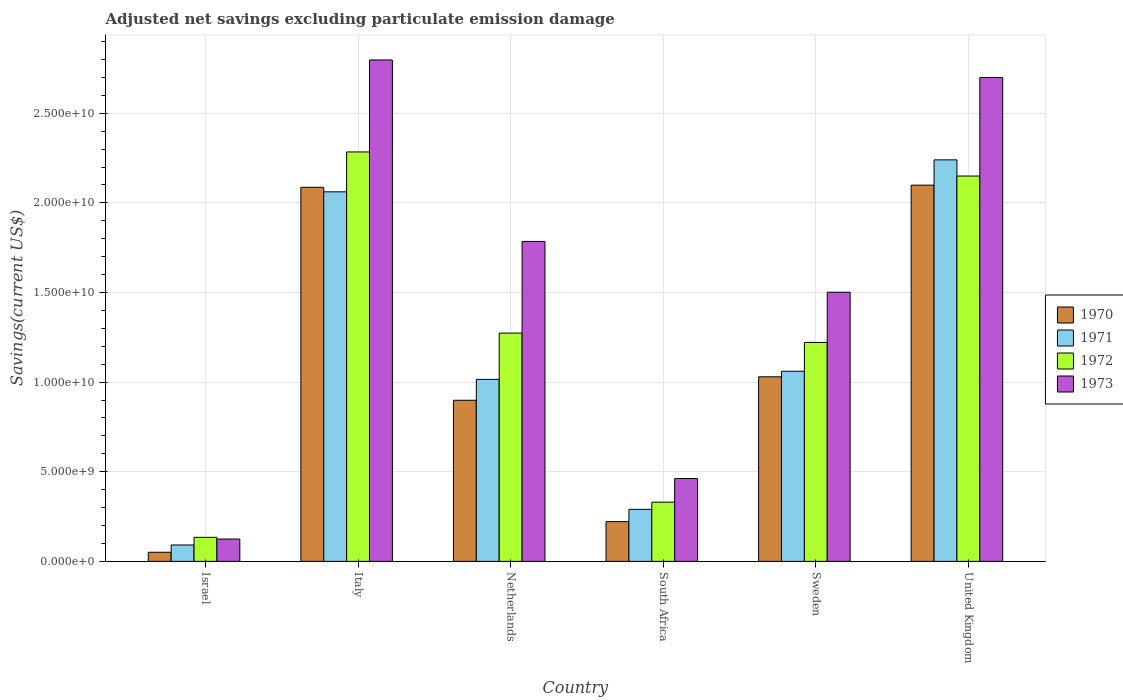How many different coloured bars are there?
Keep it short and to the point. 4. In how many cases, is the number of bars for a given country not equal to the number of legend labels?
Offer a very short reply. 0. What is the adjusted net savings in 1970 in Sweden?
Provide a succinct answer. 1.03e+1. Across all countries, what is the maximum adjusted net savings in 1973?
Your response must be concise. 2.80e+1. Across all countries, what is the minimum adjusted net savings in 1970?
Ensure brevity in your answer.  5.08e+08. What is the total adjusted net savings in 1970 in the graph?
Provide a short and direct response. 6.39e+1. What is the difference between the adjusted net savings in 1973 in Netherlands and that in South Africa?
Offer a very short reply. 1.32e+1. What is the difference between the adjusted net savings in 1972 in Sweden and the adjusted net savings in 1971 in Netherlands?
Provide a short and direct response. 2.06e+09. What is the average adjusted net savings in 1971 per country?
Your answer should be compact. 1.13e+1. What is the difference between the adjusted net savings of/in 1970 and adjusted net savings of/in 1971 in Israel?
Make the answer very short. -4.06e+08. In how many countries, is the adjusted net savings in 1973 greater than 8000000000 US$?
Offer a very short reply. 4. What is the ratio of the adjusted net savings in 1971 in Israel to that in Italy?
Make the answer very short. 0.04. Is the adjusted net savings in 1970 in Netherlands less than that in United Kingdom?
Make the answer very short. Yes. What is the difference between the highest and the second highest adjusted net savings in 1971?
Provide a short and direct response. -1.18e+1. What is the difference between the highest and the lowest adjusted net savings in 1971?
Make the answer very short. 2.15e+1. What does the 4th bar from the right in Italy represents?
Make the answer very short. 1970. Is it the case that in every country, the sum of the adjusted net savings in 1973 and adjusted net savings in 1971 is greater than the adjusted net savings in 1970?
Make the answer very short. Yes. How many bars are there?
Offer a very short reply. 24. Are all the bars in the graph horizontal?
Offer a very short reply. No. How many countries are there in the graph?
Your response must be concise. 6. What is the difference between two consecutive major ticks on the Y-axis?
Keep it short and to the point. 5.00e+09. Are the values on the major ticks of Y-axis written in scientific E-notation?
Offer a very short reply. Yes. Does the graph contain any zero values?
Your response must be concise. No. Does the graph contain grids?
Keep it short and to the point. Yes. Where does the legend appear in the graph?
Provide a short and direct response. Center right. How many legend labels are there?
Provide a succinct answer. 4. What is the title of the graph?
Offer a very short reply. Adjusted net savings excluding particulate emission damage. What is the label or title of the X-axis?
Your response must be concise. Country. What is the label or title of the Y-axis?
Ensure brevity in your answer.  Savings(current US$). What is the Savings(current US$) of 1970 in Israel?
Give a very brief answer. 5.08e+08. What is the Savings(current US$) of 1971 in Israel?
Ensure brevity in your answer.  9.14e+08. What is the Savings(current US$) of 1972 in Israel?
Offer a very short reply. 1.34e+09. What is the Savings(current US$) of 1973 in Israel?
Offer a very short reply. 1.25e+09. What is the Savings(current US$) in 1970 in Italy?
Offer a very short reply. 2.09e+1. What is the Savings(current US$) in 1971 in Italy?
Provide a short and direct response. 2.06e+1. What is the Savings(current US$) of 1972 in Italy?
Provide a short and direct response. 2.28e+1. What is the Savings(current US$) of 1973 in Italy?
Keep it short and to the point. 2.80e+1. What is the Savings(current US$) of 1970 in Netherlands?
Ensure brevity in your answer.  8.99e+09. What is the Savings(current US$) of 1971 in Netherlands?
Keep it short and to the point. 1.02e+1. What is the Savings(current US$) of 1972 in Netherlands?
Ensure brevity in your answer.  1.27e+1. What is the Savings(current US$) in 1973 in Netherlands?
Offer a very short reply. 1.79e+1. What is the Savings(current US$) in 1970 in South Africa?
Your response must be concise. 2.22e+09. What is the Savings(current US$) in 1971 in South Africa?
Your response must be concise. 2.90e+09. What is the Savings(current US$) of 1972 in South Africa?
Provide a short and direct response. 3.30e+09. What is the Savings(current US$) in 1973 in South Africa?
Keep it short and to the point. 4.62e+09. What is the Savings(current US$) of 1970 in Sweden?
Your response must be concise. 1.03e+1. What is the Savings(current US$) of 1971 in Sweden?
Keep it short and to the point. 1.06e+1. What is the Savings(current US$) of 1972 in Sweden?
Provide a succinct answer. 1.22e+1. What is the Savings(current US$) in 1973 in Sweden?
Keep it short and to the point. 1.50e+1. What is the Savings(current US$) in 1970 in United Kingdom?
Give a very brief answer. 2.10e+1. What is the Savings(current US$) in 1971 in United Kingdom?
Offer a terse response. 2.24e+1. What is the Savings(current US$) in 1972 in United Kingdom?
Make the answer very short. 2.15e+1. What is the Savings(current US$) in 1973 in United Kingdom?
Offer a very short reply. 2.70e+1. Across all countries, what is the maximum Savings(current US$) in 1970?
Make the answer very short. 2.10e+1. Across all countries, what is the maximum Savings(current US$) in 1971?
Your answer should be very brief. 2.24e+1. Across all countries, what is the maximum Savings(current US$) in 1972?
Keep it short and to the point. 2.28e+1. Across all countries, what is the maximum Savings(current US$) in 1973?
Your response must be concise. 2.80e+1. Across all countries, what is the minimum Savings(current US$) of 1970?
Ensure brevity in your answer.  5.08e+08. Across all countries, what is the minimum Savings(current US$) of 1971?
Your answer should be compact. 9.14e+08. Across all countries, what is the minimum Savings(current US$) in 1972?
Offer a very short reply. 1.34e+09. Across all countries, what is the minimum Savings(current US$) in 1973?
Offer a very short reply. 1.25e+09. What is the total Savings(current US$) of 1970 in the graph?
Provide a succinct answer. 6.39e+1. What is the total Savings(current US$) of 1971 in the graph?
Your answer should be compact. 6.76e+1. What is the total Savings(current US$) of 1972 in the graph?
Keep it short and to the point. 7.39e+1. What is the total Savings(current US$) in 1973 in the graph?
Make the answer very short. 9.37e+1. What is the difference between the Savings(current US$) in 1970 in Israel and that in Italy?
Give a very brief answer. -2.04e+1. What is the difference between the Savings(current US$) in 1971 in Israel and that in Italy?
Keep it short and to the point. -1.97e+1. What is the difference between the Savings(current US$) in 1972 in Israel and that in Italy?
Ensure brevity in your answer.  -2.15e+1. What is the difference between the Savings(current US$) in 1973 in Israel and that in Italy?
Keep it short and to the point. -2.67e+1. What is the difference between the Savings(current US$) of 1970 in Israel and that in Netherlands?
Make the answer very short. -8.48e+09. What is the difference between the Savings(current US$) in 1971 in Israel and that in Netherlands?
Provide a short and direct response. -9.24e+09. What is the difference between the Savings(current US$) in 1972 in Israel and that in Netherlands?
Provide a short and direct response. -1.14e+1. What is the difference between the Savings(current US$) of 1973 in Israel and that in Netherlands?
Provide a short and direct response. -1.66e+1. What is the difference between the Savings(current US$) in 1970 in Israel and that in South Africa?
Offer a very short reply. -1.71e+09. What is the difference between the Savings(current US$) of 1971 in Israel and that in South Africa?
Ensure brevity in your answer.  -1.99e+09. What is the difference between the Savings(current US$) of 1972 in Israel and that in South Africa?
Your answer should be compact. -1.96e+09. What is the difference between the Savings(current US$) in 1973 in Israel and that in South Africa?
Your answer should be compact. -3.38e+09. What is the difference between the Savings(current US$) in 1970 in Israel and that in Sweden?
Keep it short and to the point. -9.79e+09. What is the difference between the Savings(current US$) in 1971 in Israel and that in Sweden?
Offer a terse response. -9.69e+09. What is the difference between the Savings(current US$) of 1972 in Israel and that in Sweden?
Provide a succinct answer. -1.09e+1. What is the difference between the Savings(current US$) of 1973 in Israel and that in Sweden?
Your response must be concise. -1.38e+1. What is the difference between the Savings(current US$) of 1970 in Israel and that in United Kingdom?
Offer a terse response. -2.05e+1. What is the difference between the Savings(current US$) in 1971 in Israel and that in United Kingdom?
Offer a terse response. -2.15e+1. What is the difference between the Savings(current US$) of 1972 in Israel and that in United Kingdom?
Provide a short and direct response. -2.02e+1. What is the difference between the Savings(current US$) of 1973 in Israel and that in United Kingdom?
Offer a very short reply. -2.58e+1. What is the difference between the Savings(current US$) of 1970 in Italy and that in Netherlands?
Provide a short and direct response. 1.19e+1. What is the difference between the Savings(current US$) of 1971 in Italy and that in Netherlands?
Offer a terse response. 1.05e+1. What is the difference between the Savings(current US$) in 1972 in Italy and that in Netherlands?
Give a very brief answer. 1.01e+1. What is the difference between the Savings(current US$) in 1973 in Italy and that in Netherlands?
Keep it short and to the point. 1.01e+1. What is the difference between the Savings(current US$) of 1970 in Italy and that in South Africa?
Keep it short and to the point. 1.87e+1. What is the difference between the Savings(current US$) of 1971 in Italy and that in South Africa?
Provide a succinct answer. 1.77e+1. What is the difference between the Savings(current US$) of 1972 in Italy and that in South Africa?
Provide a succinct answer. 1.95e+1. What is the difference between the Savings(current US$) in 1973 in Italy and that in South Africa?
Give a very brief answer. 2.34e+1. What is the difference between the Savings(current US$) in 1970 in Italy and that in Sweden?
Ensure brevity in your answer.  1.06e+1. What is the difference between the Savings(current US$) in 1971 in Italy and that in Sweden?
Ensure brevity in your answer.  1.00e+1. What is the difference between the Savings(current US$) of 1972 in Italy and that in Sweden?
Give a very brief answer. 1.06e+1. What is the difference between the Savings(current US$) of 1973 in Italy and that in Sweden?
Your answer should be very brief. 1.30e+1. What is the difference between the Savings(current US$) in 1970 in Italy and that in United Kingdom?
Your response must be concise. -1.20e+08. What is the difference between the Savings(current US$) in 1971 in Italy and that in United Kingdom?
Keep it short and to the point. -1.78e+09. What is the difference between the Savings(current US$) of 1972 in Italy and that in United Kingdom?
Offer a very short reply. 1.34e+09. What is the difference between the Savings(current US$) in 1973 in Italy and that in United Kingdom?
Keep it short and to the point. 9.78e+08. What is the difference between the Savings(current US$) of 1970 in Netherlands and that in South Africa?
Offer a very short reply. 6.77e+09. What is the difference between the Savings(current US$) in 1971 in Netherlands and that in South Africa?
Your answer should be compact. 7.25e+09. What is the difference between the Savings(current US$) of 1972 in Netherlands and that in South Africa?
Offer a terse response. 9.43e+09. What is the difference between the Savings(current US$) in 1973 in Netherlands and that in South Africa?
Give a very brief answer. 1.32e+1. What is the difference between the Savings(current US$) in 1970 in Netherlands and that in Sweden?
Provide a succinct answer. -1.31e+09. What is the difference between the Savings(current US$) in 1971 in Netherlands and that in Sweden?
Your answer should be compact. -4.54e+08. What is the difference between the Savings(current US$) of 1972 in Netherlands and that in Sweden?
Keep it short and to the point. 5.20e+08. What is the difference between the Savings(current US$) in 1973 in Netherlands and that in Sweden?
Offer a terse response. 2.83e+09. What is the difference between the Savings(current US$) of 1970 in Netherlands and that in United Kingdom?
Provide a short and direct response. -1.20e+1. What is the difference between the Savings(current US$) of 1971 in Netherlands and that in United Kingdom?
Provide a short and direct response. -1.22e+1. What is the difference between the Savings(current US$) in 1972 in Netherlands and that in United Kingdom?
Ensure brevity in your answer.  -8.76e+09. What is the difference between the Savings(current US$) in 1973 in Netherlands and that in United Kingdom?
Your answer should be compact. -9.15e+09. What is the difference between the Savings(current US$) of 1970 in South Africa and that in Sweden?
Keep it short and to the point. -8.08e+09. What is the difference between the Savings(current US$) of 1971 in South Africa and that in Sweden?
Offer a very short reply. -7.70e+09. What is the difference between the Savings(current US$) in 1972 in South Africa and that in Sweden?
Offer a terse response. -8.91e+09. What is the difference between the Savings(current US$) in 1973 in South Africa and that in Sweden?
Your answer should be very brief. -1.04e+1. What is the difference between the Savings(current US$) of 1970 in South Africa and that in United Kingdom?
Provide a succinct answer. -1.88e+1. What is the difference between the Savings(current US$) in 1971 in South Africa and that in United Kingdom?
Your response must be concise. -1.95e+1. What is the difference between the Savings(current US$) in 1972 in South Africa and that in United Kingdom?
Your answer should be compact. -1.82e+1. What is the difference between the Savings(current US$) of 1973 in South Africa and that in United Kingdom?
Your answer should be very brief. -2.24e+1. What is the difference between the Savings(current US$) of 1970 in Sweden and that in United Kingdom?
Your answer should be very brief. -1.07e+1. What is the difference between the Savings(current US$) of 1971 in Sweden and that in United Kingdom?
Your response must be concise. -1.18e+1. What is the difference between the Savings(current US$) in 1972 in Sweden and that in United Kingdom?
Ensure brevity in your answer.  -9.28e+09. What is the difference between the Savings(current US$) in 1973 in Sweden and that in United Kingdom?
Ensure brevity in your answer.  -1.20e+1. What is the difference between the Savings(current US$) of 1970 in Israel and the Savings(current US$) of 1971 in Italy?
Provide a short and direct response. -2.01e+1. What is the difference between the Savings(current US$) in 1970 in Israel and the Savings(current US$) in 1972 in Italy?
Keep it short and to the point. -2.23e+1. What is the difference between the Savings(current US$) of 1970 in Israel and the Savings(current US$) of 1973 in Italy?
Your answer should be very brief. -2.75e+1. What is the difference between the Savings(current US$) of 1971 in Israel and the Savings(current US$) of 1972 in Italy?
Provide a succinct answer. -2.19e+1. What is the difference between the Savings(current US$) of 1971 in Israel and the Savings(current US$) of 1973 in Italy?
Offer a terse response. -2.71e+1. What is the difference between the Savings(current US$) in 1972 in Israel and the Savings(current US$) in 1973 in Italy?
Your response must be concise. -2.66e+1. What is the difference between the Savings(current US$) in 1970 in Israel and the Savings(current US$) in 1971 in Netherlands?
Offer a very short reply. -9.65e+09. What is the difference between the Savings(current US$) of 1970 in Israel and the Savings(current US$) of 1972 in Netherlands?
Your answer should be compact. -1.22e+1. What is the difference between the Savings(current US$) in 1970 in Israel and the Savings(current US$) in 1973 in Netherlands?
Your answer should be compact. -1.73e+1. What is the difference between the Savings(current US$) in 1971 in Israel and the Savings(current US$) in 1972 in Netherlands?
Ensure brevity in your answer.  -1.18e+1. What is the difference between the Savings(current US$) in 1971 in Israel and the Savings(current US$) in 1973 in Netherlands?
Ensure brevity in your answer.  -1.69e+1. What is the difference between the Savings(current US$) in 1972 in Israel and the Savings(current US$) in 1973 in Netherlands?
Your answer should be very brief. -1.65e+1. What is the difference between the Savings(current US$) of 1970 in Israel and the Savings(current US$) of 1971 in South Africa?
Your response must be concise. -2.39e+09. What is the difference between the Savings(current US$) in 1970 in Israel and the Savings(current US$) in 1972 in South Africa?
Give a very brief answer. -2.79e+09. What is the difference between the Savings(current US$) in 1970 in Israel and the Savings(current US$) in 1973 in South Africa?
Your response must be concise. -4.11e+09. What is the difference between the Savings(current US$) in 1971 in Israel and the Savings(current US$) in 1972 in South Africa?
Your response must be concise. -2.39e+09. What is the difference between the Savings(current US$) in 1971 in Israel and the Savings(current US$) in 1973 in South Africa?
Provide a succinct answer. -3.71e+09. What is the difference between the Savings(current US$) of 1972 in Israel and the Savings(current US$) of 1973 in South Africa?
Give a very brief answer. -3.28e+09. What is the difference between the Savings(current US$) of 1970 in Israel and the Savings(current US$) of 1971 in Sweden?
Ensure brevity in your answer.  -1.01e+1. What is the difference between the Savings(current US$) of 1970 in Israel and the Savings(current US$) of 1972 in Sweden?
Ensure brevity in your answer.  -1.17e+1. What is the difference between the Savings(current US$) in 1970 in Israel and the Savings(current US$) in 1973 in Sweden?
Provide a succinct answer. -1.45e+1. What is the difference between the Savings(current US$) in 1971 in Israel and the Savings(current US$) in 1972 in Sweden?
Ensure brevity in your answer.  -1.13e+1. What is the difference between the Savings(current US$) of 1971 in Israel and the Savings(current US$) of 1973 in Sweden?
Keep it short and to the point. -1.41e+1. What is the difference between the Savings(current US$) in 1972 in Israel and the Savings(current US$) in 1973 in Sweden?
Make the answer very short. -1.37e+1. What is the difference between the Savings(current US$) of 1970 in Israel and the Savings(current US$) of 1971 in United Kingdom?
Your response must be concise. -2.19e+1. What is the difference between the Savings(current US$) in 1970 in Israel and the Savings(current US$) in 1972 in United Kingdom?
Offer a terse response. -2.10e+1. What is the difference between the Savings(current US$) of 1970 in Israel and the Savings(current US$) of 1973 in United Kingdom?
Keep it short and to the point. -2.65e+1. What is the difference between the Savings(current US$) in 1971 in Israel and the Savings(current US$) in 1972 in United Kingdom?
Your response must be concise. -2.06e+1. What is the difference between the Savings(current US$) in 1971 in Israel and the Savings(current US$) in 1973 in United Kingdom?
Offer a very short reply. -2.61e+1. What is the difference between the Savings(current US$) of 1972 in Israel and the Savings(current US$) of 1973 in United Kingdom?
Provide a short and direct response. -2.57e+1. What is the difference between the Savings(current US$) in 1970 in Italy and the Savings(current US$) in 1971 in Netherlands?
Provide a short and direct response. 1.07e+1. What is the difference between the Savings(current US$) of 1970 in Italy and the Savings(current US$) of 1972 in Netherlands?
Provide a succinct answer. 8.14e+09. What is the difference between the Savings(current US$) of 1970 in Italy and the Savings(current US$) of 1973 in Netherlands?
Give a very brief answer. 3.02e+09. What is the difference between the Savings(current US$) of 1971 in Italy and the Savings(current US$) of 1972 in Netherlands?
Your response must be concise. 7.88e+09. What is the difference between the Savings(current US$) in 1971 in Italy and the Savings(current US$) in 1973 in Netherlands?
Your answer should be compact. 2.77e+09. What is the difference between the Savings(current US$) of 1972 in Italy and the Savings(current US$) of 1973 in Netherlands?
Give a very brief answer. 4.99e+09. What is the difference between the Savings(current US$) of 1970 in Italy and the Savings(current US$) of 1971 in South Africa?
Offer a very short reply. 1.80e+1. What is the difference between the Savings(current US$) in 1970 in Italy and the Savings(current US$) in 1972 in South Africa?
Offer a very short reply. 1.76e+1. What is the difference between the Savings(current US$) in 1970 in Italy and the Savings(current US$) in 1973 in South Africa?
Your answer should be very brief. 1.62e+1. What is the difference between the Savings(current US$) of 1971 in Italy and the Savings(current US$) of 1972 in South Africa?
Your response must be concise. 1.73e+1. What is the difference between the Savings(current US$) in 1971 in Italy and the Savings(current US$) in 1973 in South Africa?
Your answer should be very brief. 1.60e+1. What is the difference between the Savings(current US$) of 1972 in Italy and the Savings(current US$) of 1973 in South Africa?
Provide a succinct answer. 1.82e+1. What is the difference between the Savings(current US$) of 1970 in Italy and the Savings(current US$) of 1971 in Sweden?
Your response must be concise. 1.03e+1. What is the difference between the Savings(current US$) in 1970 in Italy and the Savings(current US$) in 1972 in Sweden?
Your response must be concise. 8.66e+09. What is the difference between the Savings(current US$) in 1970 in Italy and the Savings(current US$) in 1973 in Sweden?
Keep it short and to the point. 5.85e+09. What is the difference between the Savings(current US$) of 1971 in Italy and the Savings(current US$) of 1972 in Sweden?
Make the answer very short. 8.40e+09. What is the difference between the Savings(current US$) of 1971 in Italy and the Savings(current US$) of 1973 in Sweden?
Your response must be concise. 5.60e+09. What is the difference between the Savings(current US$) in 1972 in Italy and the Savings(current US$) in 1973 in Sweden?
Keep it short and to the point. 7.83e+09. What is the difference between the Savings(current US$) in 1970 in Italy and the Savings(current US$) in 1971 in United Kingdom?
Make the answer very short. -1.53e+09. What is the difference between the Savings(current US$) of 1970 in Italy and the Savings(current US$) of 1972 in United Kingdom?
Make the answer very short. -6.28e+08. What is the difference between the Savings(current US$) of 1970 in Italy and the Savings(current US$) of 1973 in United Kingdom?
Make the answer very short. -6.13e+09. What is the difference between the Savings(current US$) in 1971 in Italy and the Savings(current US$) in 1972 in United Kingdom?
Provide a succinct answer. -8.80e+08. What is the difference between the Savings(current US$) of 1971 in Italy and the Savings(current US$) of 1973 in United Kingdom?
Your answer should be very brief. -6.38e+09. What is the difference between the Savings(current US$) in 1972 in Italy and the Savings(current US$) in 1973 in United Kingdom?
Your response must be concise. -4.15e+09. What is the difference between the Savings(current US$) in 1970 in Netherlands and the Savings(current US$) in 1971 in South Africa?
Make the answer very short. 6.09e+09. What is the difference between the Savings(current US$) in 1970 in Netherlands and the Savings(current US$) in 1972 in South Africa?
Make the answer very short. 5.69e+09. What is the difference between the Savings(current US$) in 1970 in Netherlands and the Savings(current US$) in 1973 in South Africa?
Offer a terse response. 4.37e+09. What is the difference between the Savings(current US$) of 1971 in Netherlands and the Savings(current US$) of 1972 in South Africa?
Your answer should be very brief. 6.85e+09. What is the difference between the Savings(current US$) of 1971 in Netherlands and the Savings(current US$) of 1973 in South Africa?
Your response must be concise. 5.53e+09. What is the difference between the Savings(current US$) of 1972 in Netherlands and the Savings(current US$) of 1973 in South Africa?
Offer a terse response. 8.11e+09. What is the difference between the Savings(current US$) in 1970 in Netherlands and the Savings(current US$) in 1971 in Sweden?
Your answer should be compact. -1.62e+09. What is the difference between the Savings(current US$) in 1970 in Netherlands and the Savings(current US$) in 1972 in Sweden?
Provide a short and direct response. -3.23e+09. What is the difference between the Savings(current US$) of 1970 in Netherlands and the Savings(current US$) of 1973 in Sweden?
Your response must be concise. -6.03e+09. What is the difference between the Savings(current US$) in 1971 in Netherlands and the Savings(current US$) in 1972 in Sweden?
Offer a terse response. -2.06e+09. What is the difference between the Savings(current US$) of 1971 in Netherlands and the Savings(current US$) of 1973 in Sweden?
Keep it short and to the point. -4.86e+09. What is the difference between the Savings(current US$) in 1972 in Netherlands and the Savings(current US$) in 1973 in Sweden?
Offer a terse response. -2.28e+09. What is the difference between the Savings(current US$) in 1970 in Netherlands and the Savings(current US$) in 1971 in United Kingdom?
Offer a terse response. -1.34e+1. What is the difference between the Savings(current US$) of 1970 in Netherlands and the Savings(current US$) of 1972 in United Kingdom?
Make the answer very short. -1.25e+1. What is the difference between the Savings(current US$) of 1970 in Netherlands and the Savings(current US$) of 1973 in United Kingdom?
Offer a very short reply. -1.80e+1. What is the difference between the Savings(current US$) in 1971 in Netherlands and the Savings(current US$) in 1972 in United Kingdom?
Offer a terse response. -1.13e+1. What is the difference between the Savings(current US$) in 1971 in Netherlands and the Savings(current US$) in 1973 in United Kingdom?
Offer a terse response. -1.68e+1. What is the difference between the Savings(current US$) of 1972 in Netherlands and the Savings(current US$) of 1973 in United Kingdom?
Offer a very short reply. -1.43e+1. What is the difference between the Savings(current US$) of 1970 in South Africa and the Savings(current US$) of 1971 in Sweden?
Offer a terse response. -8.39e+09. What is the difference between the Savings(current US$) of 1970 in South Africa and the Savings(current US$) of 1972 in Sweden?
Ensure brevity in your answer.  -1.00e+1. What is the difference between the Savings(current US$) in 1970 in South Africa and the Savings(current US$) in 1973 in Sweden?
Offer a very short reply. -1.28e+1. What is the difference between the Savings(current US$) of 1971 in South Africa and the Savings(current US$) of 1972 in Sweden?
Your response must be concise. -9.31e+09. What is the difference between the Savings(current US$) of 1971 in South Africa and the Savings(current US$) of 1973 in Sweden?
Offer a terse response. -1.21e+1. What is the difference between the Savings(current US$) in 1972 in South Africa and the Savings(current US$) in 1973 in Sweden?
Your answer should be compact. -1.17e+1. What is the difference between the Savings(current US$) in 1970 in South Africa and the Savings(current US$) in 1971 in United Kingdom?
Offer a terse response. -2.02e+1. What is the difference between the Savings(current US$) of 1970 in South Africa and the Savings(current US$) of 1972 in United Kingdom?
Your answer should be compact. -1.93e+1. What is the difference between the Savings(current US$) of 1970 in South Africa and the Savings(current US$) of 1973 in United Kingdom?
Provide a succinct answer. -2.48e+1. What is the difference between the Savings(current US$) in 1971 in South Africa and the Savings(current US$) in 1972 in United Kingdom?
Give a very brief answer. -1.86e+1. What is the difference between the Savings(current US$) of 1971 in South Africa and the Savings(current US$) of 1973 in United Kingdom?
Your answer should be very brief. -2.41e+1. What is the difference between the Savings(current US$) of 1972 in South Africa and the Savings(current US$) of 1973 in United Kingdom?
Offer a very short reply. -2.37e+1. What is the difference between the Savings(current US$) of 1970 in Sweden and the Savings(current US$) of 1971 in United Kingdom?
Your answer should be compact. -1.21e+1. What is the difference between the Savings(current US$) of 1970 in Sweden and the Savings(current US$) of 1972 in United Kingdom?
Offer a very short reply. -1.12e+1. What is the difference between the Savings(current US$) of 1970 in Sweden and the Savings(current US$) of 1973 in United Kingdom?
Keep it short and to the point. -1.67e+1. What is the difference between the Savings(current US$) of 1971 in Sweden and the Savings(current US$) of 1972 in United Kingdom?
Your answer should be compact. -1.09e+1. What is the difference between the Savings(current US$) in 1971 in Sweden and the Savings(current US$) in 1973 in United Kingdom?
Make the answer very short. -1.64e+1. What is the difference between the Savings(current US$) in 1972 in Sweden and the Savings(current US$) in 1973 in United Kingdom?
Your answer should be very brief. -1.48e+1. What is the average Savings(current US$) in 1970 per country?
Provide a succinct answer. 1.06e+1. What is the average Savings(current US$) of 1971 per country?
Provide a succinct answer. 1.13e+1. What is the average Savings(current US$) of 1972 per country?
Your response must be concise. 1.23e+1. What is the average Savings(current US$) in 1973 per country?
Make the answer very short. 1.56e+1. What is the difference between the Savings(current US$) in 1970 and Savings(current US$) in 1971 in Israel?
Your answer should be compact. -4.06e+08. What is the difference between the Savings(current US$) of 1970 and Savings(current US$) of 1972 in Israel?
Offer a terse response. -8.33e+08. What is the difference between the Savings(current US$) in 1970 and Savings(current US$) in 1973 in Israel?
Offer a very short reply. -7.39e+08. What is the difference between the Savings(current US$) of 1971 and Savings(current US$) of 1972 in Israel?
Your response must be concise. -4.27e+08. What is the difference between the Savings(current US$) in 1971 and Savings(current US$) in 1973 in Israel?
Offer a terse response. -3.33e+08. What is the difference between the Savings(current US$) in 1972 and Savings(current US$) in 1973 in Israel?
Your response must be concise. 9.40e+07. What is the difference between the Savings(current US$) in 1970 and Savings(current US$) in 1971 in Italy?
Give a very brief answer. 2.53e+08. What is the difference between the Savings(current US$) of 1970 and Savings(current US$) of 1972 in Italy?
Ensure brevity in your answer.  -1.97e+09. What is the difference between the Savings(current US$) of 1970 and Savings(current US$) of 1973 in Italy?
Keep it short and to the point. -7.11e+09. What is the difference between the Savings(current US$) of 1971 and Savings(current US$) of 1972 in Italy?
Your answer should be compact. -2.23e+09. What is the difference between the Savings(current US$) in 1971 and Savings(current US$) in 1973 in Italy?
Your response must be concise. -7.36e+09. What is the difference between the Savings(current US$) in 1972 and Savings(current US$) in 1973 in Italy?
Your answer should be very brief. -5.13e+09. What is the difference between the Savings(current US$) in 1970 and Savings(current US$) in 1971 in Netherlands?
Your response must be concise. -1.17e+09. What is the difference between the Savings(current US$) in 1970 and Savings(current US$) in 1972 in Netherlands?
Keep it short and to the point. -3.75e+09. What is the difference between the Savings(current US$) in 1970 and Savings(current US$) in 1973 in Netherlands?
Provide a succinct answer. -8.86e+09. What is the difference between the Savings(current US$) of 1971 and Savings(current US$) of 1972 in Netherlands?
Provide a succinct answer. -2.58e+09. What is the difference between the Savings(current US$) of 1971 and Savings(current US$) of 1973 in Netherlands?
Provide a short and direct response. -7.70e+09. What is the difference between the Savings(current US$) in 1972 and Savings(current US$) in 1973 in Netherlands?
Provide a succinct answer. -5.11e+09. What is the difference between the Savings(current US$) in 1970 and Savings(current US$) in 1971 in South Africa?
Provide a short and direct response. -6.85e+08. What is the difference between the Savings(current US$) in 1970 and Savings(current US$) in 1972 in South Africa?
Ensure brevity in your answer.  -1.08e+09. What is the difference between the Savings(current US$) of 1970 and Savings(current US$) of 1973 in South Africa?
Offer a terse response. -2.40e+09. What is the difference between the Savings(current US$) of 1971 and Savings(current US$) of 1972 in South Africa?
Offer a very short reply. -4.00e+08. What is the difference between the Savings(current US$) of 1971 and Savings(current US$) of 1973 in South Africa?
Make the answer very short. -1.72e+09. What is the difference between the Savings(current US$) in 1972 and Savings(current US$) in 1973 in South Africa?
Provide a short and direct response. -1.32e+09. What is the difference between the Savings(current US$) in 1970 and Savings(current US$) in 1971 in Sweden?
Ensure brevity in your answer.  -3.10e+08. What is the difference between the Savings(current US$) in 1970 and Savings(current US$) in 1972 in Sweden?
Your answer should be very brief. -1.92e+09. What is the difference between the Savings(current US$) in 1970 and Savings(current US$) in 1973 in Sweden?
Offer a very short reply. -4.72e+09. What is the difference between the Savings(current US$) of 1971 and Savings(current US$) of 1972 in Sweden?
Your response must be concise. -1.61e+09. What is the difference between the Savings(current US$) in 1971 and Savings(current US$) in 1973 in Sweden?
Offer a terse response. -4.41e+09. What is the difference between the Savings(current US$) of 1972 and Savings(current US$) of 1973 in Sweden?
Your answer should be compact. -2.80e+09. What is the difference between the Savings(current US$) of 1970 and Savings(current US$) of 1971 in United Kingdom?
Make the answer very short. -1.41e+09. What is the difference between the Savings(current US$) in 1970 and Savings(current US$) in 1972 in United Kingdom?
Ensure brevity in your answer.  -5.08e+08. What is the difference between the Savings(current US$) in 1970 and Savings(current US$) in 1973 in United Kingdom?
Offer a terse response. -6.01e+09. What is the difference between the Savings(current US$) in 1971 and Savings(current US$) in 1972 in United Kingdom?
Your answer should be very brief. 9.03e+08. What is the difference between the Savings(current US$) in 1971 and Savings(current US$) in 1973 in United Kingdom?
Provide a succinct answer. -4.60e+09. What is the difference between the Savings(current US$) of 1972 and Savings(current US$) of 1973 in United Kingdom?
Provide a short and direct response. -5.50e+09. What is the ratio of the Savings(current US$) of 1970 in Israel to that in Italy?
Provide a short and direct response. 0.02. What is the ratio of the Savings(current US$) in 1971 in Israel to that in Italy?
Keep it short and to the point. 0.04. What is the ratio of the Savings(current US$) of 1972 in Israel to that in Italy?
Provide a succinct answer. 0.06. What is the ratio of the Savings(current US$) in 1973 in Israel to that in Italy?
Provide a short and direct response. 0.04. What is the ratio of the Savings(current US$) of 1970 in Israel to that in Netherlands?
Provide a succinct answer. 0.06. What is the ratio of the Savings(current US$) of 1971 in Israel to that in Netherlands?
Your answer should be very brief. 0.09. What is the ratio of the Savings(current US$) in 1972 in Israel to that in Netherlands?
Your answer should be very brief. 0.11. What is the ratio of the Savings(current US$) of 1973 in Israel to that in Netherlands?
Your answer should be compact. 0.07. What is the ratio of the Savings(current US$) in 1970 in Israel to that in South Africa?
Your answer should be compact. 0.23. What is the ratio of the Savings(current US$) in 1971 in Israel to that in South Africa?
Provide a short and direct response. 0.32. What is the ratio of the Savings(current US$) of 1972 in Israel to that in South Africa?
Offer a very short reply. 0.41. What is the ratio of the Savings(current US$) in 1973 in Israel to that in South Africa?
Offer a very short reply. 0.27. What is the ratio of the Savings(current US$) in 1970 in Israel to that in Sweden?
Ensure brevity in your answer.  0.05. What is the ratio of the Savings(current US$) in 1971 in Israel to that in Sweden?
Give a very brief answer. 0.09. What is the ratio of the Savings(current US$) in 1972 in Israel to that in Sweden?
Your answer should be very brief. 0.11. What is the ratio of the Savings(current US$) of 1973 in Israel to that in Sweden?
Offer a terse response. 0.08. What is the ratio of the Savings(current US$) of 1970 in Israel to that in United Kingdom?
Your answer should be compact. 0.02. What is the ratio of the Savings(current US$) in 1971 in Israel to that in United Kingdom?
Provide a succinct answer. 0.04. What is the ratio of the Savings(current US$) in 1972 in Israel to that in United Kingdom?
Give a very brief answer. 0.06. What is the ratio of the Savings(current US$) of 1973 in Israel to that in United Kingdom?
Keep it short and to the point. 0.05. What is the ratio of the Savings(current US$) of 1970 in Italy to that in Netherlands?
Your answer should be very brief. 2.32. What is the ratio of the Savings(current US$) of 1971 in Italy to that in Netherlands?
Ensure brevity in your answer.  2.03. What is the ratio of the Savings(current US$) in 1972 in Italy to that in Netherlands?
Provide a succinct answer. 1.79. What is the ratio of the Savings(current US$) of 1973 in Italy to that in Netherlands?
Your answer should be very brief. 1.57. What is the ratio of the Savings(current US$) in 1970 in Italy to that in South Africa?
Your answer should be compact. 9.41. What is the ratio of the Savings(current US$) in 1971 in Italy to that in South Africa?
Provide a short and direct response. 7.1. What is the ratio of the Savings(current US$) in 1972 in Italy to that in South Africa?
Your answer should be very brief. 6.92. What is the ratio of the Savings(current US$) in 1973 in Italy to that in South Africa?
Provide a short and direct response. 6.05. What is the ratio of the Savings(current US$) of 1970 in Italy to that in Sweden?
Offer a terse response. 2.03. What is the ratio of the Savings(current US$) of 1971 in Italy to that in Sweden?
Offer a terse response. 1.94. What is the ratio of the Savings(current US$) in 1972 in Italy to that in Sweden?
Give a very brief answer. 1.87. What is the ratio of the Savings(current US$) in 1973 in Italy to that in Sweden?
Give a very brief answer. 1.86. What is the ratio of the Savings(current US$) of 1971 in Italy to that in United Kingdom?
Your answer should be very brief. 0.92. What is the ratio of the Savings(current US$) of 1972 in Italy to that in United Kingdom?
Offer a very short reply. 1.06. What is the ratio of the Savings(current US$) in 1973 in Italy to that in United Kingdom?
Your response must be concise. 1.04. What is the ratio of the Savings(current US$) in 1970 in Netherlands to that in South Africa?
Provide a succinct answer. 4.05. What is the ratio of the Savings(current US$) in 1971 in Netherlands to that in South Africa?
Ensure brevity in your answer.  3.5. What is the ratio of the Savings(current US$) in 1972 in Netherlands to that in South Africa?
Your response must be concise. 3.86. What is the ratio of the Savings(current US$) in 1973 in Netherlands to that in South Africa?
Your response must be concise. 3.86. What is the ratio of the Savings(current US$) of 1970 in Netherlands to that in Sweden?
Ensure brevity in your answer.  0.87. What is the ratio of the Savings(current US$) of 1971 in Netherlands to that in Sweden?
Your response must be concise. 0.96. What is the ratio of the Savings(current US$) of 1972 in Netherlands to that in Sweden?
Offer a terse response. 1.04. What is the ratio of the Savings(current US$) in 1973 in Netherlands to that in Sweden?
Your answer should be compact. 1.19. What is the ratio of the Savings(current US$) of 1970 in Netherlands to that in United Kingdom?
Make the answer very short. 0.43. What is the ratio of the Savings(current US$) in 1971 in Netherlands to that in United Kingdom?
Your answer should be compact. 0.45. What is the ratio of the Savings(current US$) of 1972 in Netherlands to that in United Kingdom?
Provide a short and direct response. 0.59. What is the ratio of the Savings(current US$) in 1973 in Netherlands to that in United Kingdom?
Your answer should be very brief. 0.66. What is the ratio of the Savings(current US$) of 1970 in South Africa to that in Sweden?
Provide a short and direct response. 0.22. What is the ratio of the Savings(current US$) in 1971 in South Africa to that in Sweden?
Your response must be concise. 0.27. What is the ratio of the Savings(current US$) of 1972 in South Africa to that in Sweden?
Provide a succinct answer. 0.27. What is the ratio of the Savings(current US$) in 1973 in South Africa to that in Sweden?
Make the answer very short. 0.31. What is the ratio of the Savings(current US$) of 1970 in South Africa to that in United Kingdom?
Offer a very short reply. 0.11. What is the ratio of the Savings(current US$) of 1971 in South Africa to that in United Kingdom?
Your answer should be very brief. 0.13. What is the ratio of the Savings(current US$) in 1972 in South Africa to that in United Kingdom?
Your response must be concise. 0.15. What is the ratio of the Savings(current US$) of 1973 in South Africa to that in United Kingdom?
Your answer should be very brief. 0.17. What is the ratio of the Savings(current US$) in 1970 in Sweden to that in United Kingdom?
Your response must be concise. 0.49. What is the ratio of the Savings(current US$) in 1971 in Sweden to that in United Kingdom?
Provide a short and direct response. 0.47. What is the ratio of the Savings(current US$) of 1972 in Sweden to that in United Kingdom?
Offer a very short reply. 0.57. What is the ratio of the Savings(current US$) of 1973 in Sweden to that in United Kingdom?
Provide a succinct answer. 0.56. What is the difference between the highest and the second highest Savings(current US$) of 1970?
Give a very brief answer. 1.20e+08. What is the difference between the highest and the second highest Savings(current US$) of 1971?
Give a very brief answer. 1.78e+09. What is the difference between the highest and the second highest Savings(current US$) of 1972?
Ensure brevity in your answer.  1.34e+09. What is the difference between the highest and the second highest Savings(current US$) in 1973?
Provide a succinct answer. 9.78e+08. What is the difference between the highest and the lowest Savings(current US$) in 1970?
Provide a short and direct response. 2.05e+1. What is the difference between the highest and the lowest Savings(current US$) of 1971?
Your answer should be compact. 2.15e+1. What is the difference between the highest and the lowest Savings(current US$) in 1972?
Ensure brevity in your answer.  2.15e+1. What is the difference between the highest and the lowest Savings(current US$) in 1973?
Your answer should be very brief. 2.67e+1. 